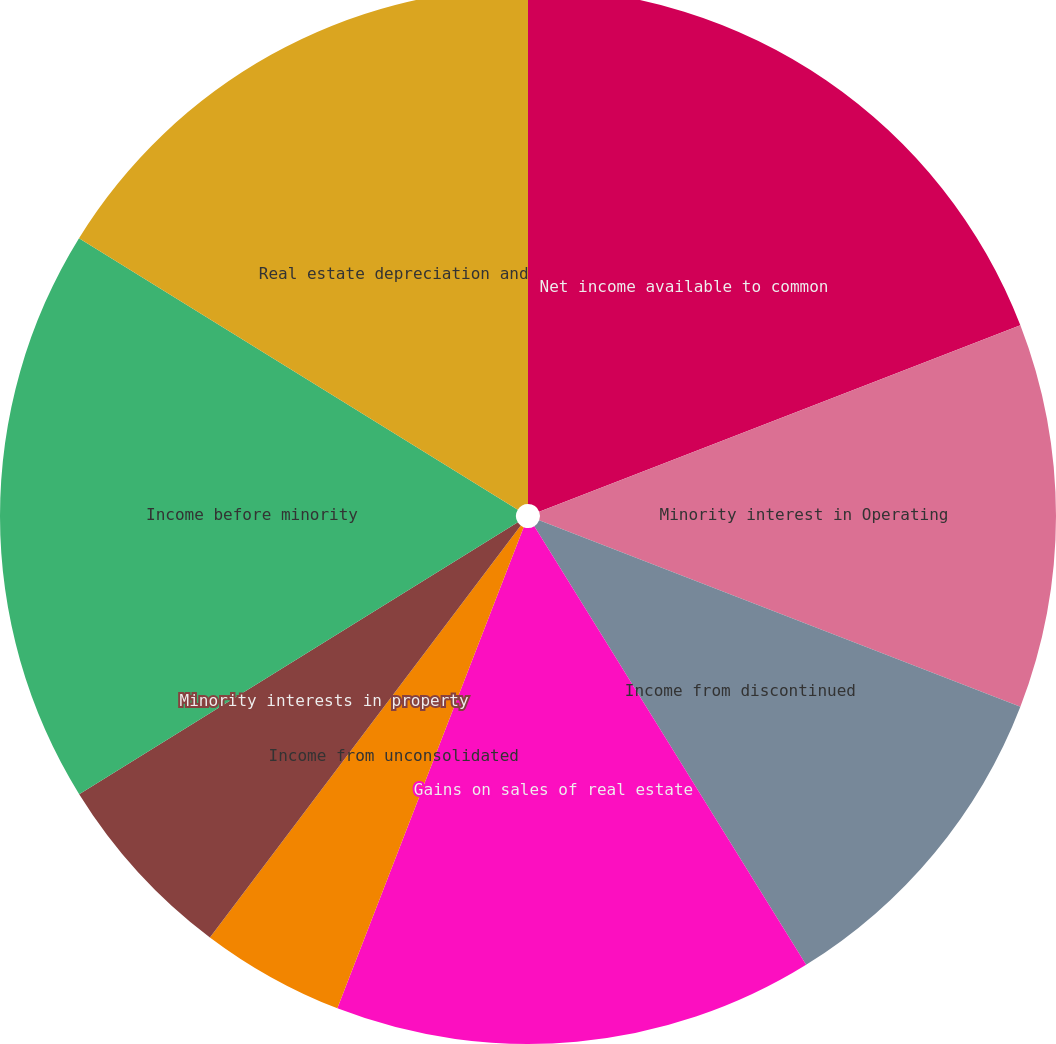<chart> <loc_0><loc_0><loc_500><loc_500><pie_chart><fcel>Net income available to common<fcel>Minority interest in Operating<fcel>Income from discontinued<fcel>Gains on sales of real estate<fcel>Income from unconsolidated<fcel>Minority interests in property<fcel>Income before minority<fcel>Real estate depreciation and<nl><fcel>19.12%<fcel>11.76%<fcel>10.29%<fcel>14.71%<fcel>4.41%<fcel>5.88%<fcel>17.65%<fcel>16.18%<nl></chart> 